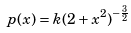Convert formula to latex. <formula><loc_0><loc_0><loc_500><loc_500>p ( x ) = k ( 2 + x ^ { 2 } ) ^ { - \frac { 3 } { 2 } }</formula> 